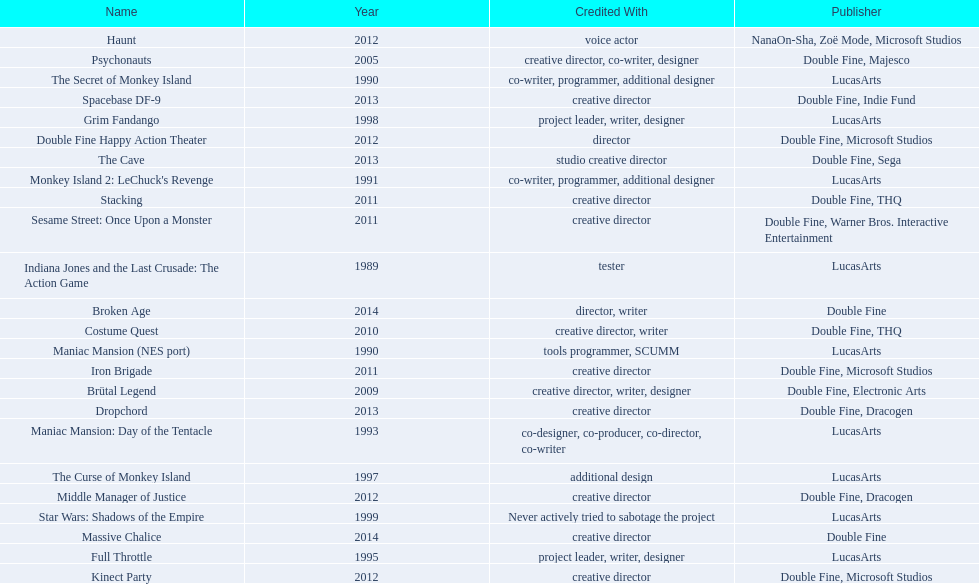Which game is credited with a creative director? Creative director, co-writer, designer, creative director, writer, designer, creative director, writer, creative director, creative director, creative director, creative director, creative director, creative director, creative director, creative director. Of these games, which also has warner bros. interactive listed as creative director? Sesame Street: Once Upon a Monster. 